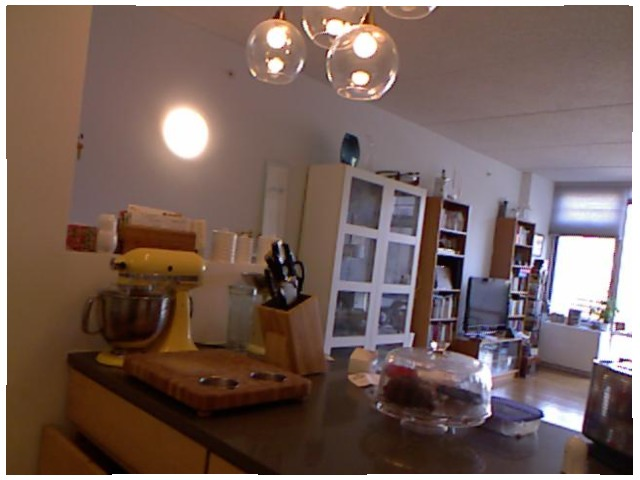<image>
Can you confirm if the cake is under the dish? Yes. The cake is positioned underneath the dish, with the dish above it in the vertical space. Is there a light under the table? No. The light is not positioned under the table. The vertical relationship between these objects is different. Is there a tv on the wall? No. The tv is not positioned on the wall. They may be near each other, but the tv is not supported by or resting on top of the wall. Is the light above the table? Yes. The light is positioned above the table in the vertical space, higher up in the scene. 